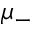<formula> <loc_0><loc_0><loc_500><loc_500>\mu _ { - }</formula> 